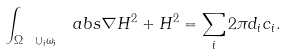Convert formula to latex. <formula><loc_0><loc_0><loc_500><loc_500>\int _ { \Omega \ \cup _ { i } \omega _ { i } } \ a b s { \nabla H } ^ { 2 } + H ^ { 2 } = \sum _ { i } 2 \pi d _ { i } c _ { i } .</formula> 